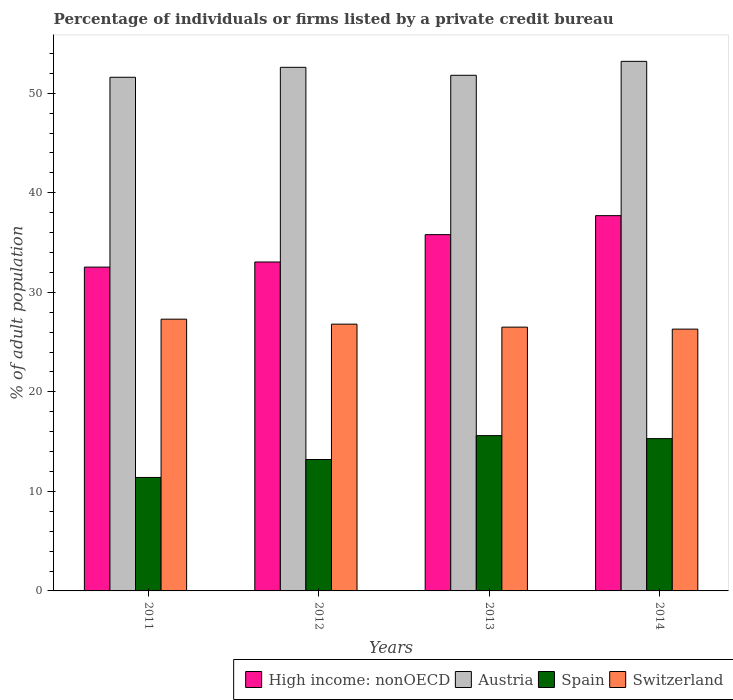How many different coloured bars are there?
Give a very brief answer. 4. Are the number of bars on each tick of the X-axis equal?
Ensure brevity in your answer.  Yes. How many bars are there on the 3rd tick from the right?
Ensure brevity in your answer.  4. What is the label of the 3rd group of bars from the left?
Your answer should be very brief. 2013. In how many cases, is the number of bars for a given year not equal to the number of legend labels?
Offer a very short reply. 0. Across all years, what is the maximum percentage of population listed by a private credit bureau in Spain?
Your answer should be compact. 15.6. Across all years, what is the minimum percentage of population listed by a private credit bureau in High income: nonOECD?
Your response must be concise. 32.53. In which year was the percentage of population listed by a private credit bureau in Austria maximum?
Offer a terse response. 2014. What is the total percentage of population listed by a private credit bureau in Spain in the graph?
Provide a succinct answer. 55.5. What is the difference between the percentage of population listed by a private credit bureau in Spain in 2011 and that in 2014?
Provide a short and direct response. -3.9. What is the difference between the percentage of population listed by a private credit bureau in Switzerland in 2012 and the percentage of population listed by a private credit bureau in High income: nonOECD in 2013?
Keep it short and to the point. -8.99. What is the average percentage of population listed by a private credit bureau in Switzerland per year?
Your answer should be compact. 26.72. In the year 2014, what is the difference between the percentage of population listed by a private credit bureau in Austria and percentage of population listed by a private credit bureau in High income: nonOECD?
Offer a terse response. 15.5. In how many years, is the percentage of population listed by a private credit bureau in Spain greater than 50 %?
Your response must be concise. 0. What is the ratio of the percentage of population listed by a private credit bureau in High income: nonOECD in 2013 to that in 2014?
Keep it short and to the point. 0.95. What is the difference between the highest and the second highest percentage of population listed by a private credit bureau in Austria?
Offer a terse response. 0.6. What is the difference between the highest and the lowest percentage of population listed by a private credit bureau in High income: nonOECD?
Offer a very short reply. 5.17. In how many years, is the percentage of population listed by a private credit bureau in High income: nonOECD greater than the average percentage of population listed by a private credit bureau in High income: nonOECD taken over all years?
Your response must be concise. 2. Is the sum of the percentage of population listed by a private credit bureau in Austria in 2012 and 2014 greater than the maximum percentage of population listed by a private credit bureau in High income: nonOECD across all years?
Ensure brevity in your answer.  Yes. What does the 1st bar from the left in 2011 represents?
Provide a succinct answer. High income: nonOECD. What does the 2nd bar from the right in 2012 represents?
Ensure brevity in your answer.  Spain. How many bars are there?
Provide a short and direct response. 16. Are all the bars in the graph horizontal?
Keep it short and to the point. No. How many years are there in the graph?
Make the answer very short. 4. What is the difference between two consecutive major ticks on the Y-axis?
Offer a very short reply. 10. Are the values on the major ticks of Y-axis written in scientific E-notation?
Your answer should be compact. No. Does the graph contain any zero values?
Keep it short and to the point. No. Where does the legend appear in the graph?
Ensure brevity in your answer.  Bottom right. How many legend labels are there?
Your answer should be very brief. 4. How are the legend labels stacked?
Offer a very short reply. Horizontal. What is the title of the graph?
Make the answer very short. Percentage of individuals or firms listed by a private credit bureau. What is the label or title of the Y-axis?
Provide a short and direct response. % of adult population. What is the % of adult population in High income: nonOECD in 2011?
Provide a short and direct response. 32.53. What is the % of adult population of Austria in 2011?
Provide a short and direct response. 51.6. What is the % of adult population of Switzerland in 2011?
Give a very brief answer. 27.3. What is the % of adult population in High income: nonOECD in 2012?
Provide a short and direct response. 33.04. What is the % of adult population of Austria in 2012?
Offer a terse response. 52.6. What is the % of adult population of Switzerland in 2012?
Provide a succinct answer. 26.8. What is the % of adult population of High income: nonOECD in 2013?
Your answer should be compact. 35.79. What is the % of adult population of Austria in 2013?
Offer a terse response. 51.8. What is the % of adult population of Switzerland in 2013?
Offer a terse response. 26.5. What is the % of adult population in High income: nonOECD in 2014?
Keep it short and to the point. 37.7. What is the % of adult population of Austria in 2014?
Provide a succinct answer. 53.2. What is the % of adult population of Switzerland in 2014?
Offer a very short reply. 26.3. Across all years, what is the maximum % of adult population of High income: nonOECD?
Offer a terse response. 37.7. Across all years, what is the maximum % of adult population in Austria?
Keep it short and to the point. 53.2. Across all years, what is the maximum % of adult population in Switzerland?
Ensure brevity in your answer.  27.3. Across all years, what is the minimum % of adult population of High income: nonOECD?
Make the answer very short. 32.53. Across all years, what is the minimum % of adult population in Austria?
Make the answer very short. 51.6. Across all years, what is the minimum % of adult population of Switzerland?
Your answer should be very brief. 26.3. What is the total % of adult population of High income: nonOECD in the graph?
Your answer should be very brief. 139.07. What is the total % of adult population of Austria in the graph?
Offer a terse response. 209.2. What is the total % of adult population of Spain in the graph?
Offer a very short reply. 55.5. What is the total % of adult population of Switzerland in the graph?
Offer a very short reply. 106.9. What is the difference between the % of adult population in High income: nonOECD in 2011 and that in 2012?
Make the answer very short. -0.51. What is the difference between the % of adult population in Spain in 2011 and that in 2012?
Keep it short and to the point. -1.8. What is the difference between the % of adult population of High income: nonOECD in 2011 and that in 2013?
Ensure brevity in your answer.  -3.26. What is the difference between the % of adult population of Austria in 2011 and that in 2013?
Your answer should be very brief. -0.2. What is the difference between the % of adult population in High income: nonOECD in 2011 and that in 2014?
Give a very brief answer. -5.17. What is the difference between the % of adult population in High income: nonOECD in 2012 and that in 2013?
Make the answer very short. -2.75. What is the difference between the % of adult population in Spain in 2012 and that in 2013?
Offer a very short reply. -2.4. What is the difference between the % of adult population of High income: nonOECD in 2012 and that in 2014?
Provide a succinct answer. -4.66. What is the difference between the % of adult population of Austria in 2012 and that in 2014?
Your answer should be compact. -0.6. What is the difference between the % of adult population of Spain in 2012 and that in 2014?
Make the answer very short. -2.1. What is the difference between the % of adult population in Switzerland in 2012 and that in 2014?
Your answer should be very brief. 0.5. What is the difference between the % of adult population in High income: nonOECD in 2013 and that in 2014?
Give a very brief answer. -1.91. What is the difference between the % of adult population of Austria in 2013 and that in 2014?
Provide a short and direct response. -1.4. What is the difference between the % of adult population of High income: nonOECD in 2011 and the % of adult population of Austria in 2012?
Give a very brief answer. -20.07. What is the difference between the % of adult population of High income: nonOECD in 2011 and the % of adult population of Spain in 2012?
Provide a short and direct response. 19.33. What is the difference between the % of adult population of High income: nonOECD in 2011 and the % of adult population of Switzerland in 2012?
Offer a terse response. 5.73. What is the difference between the % of adult population of Austria in 2011 and the % of adult population of Spain in 2012?
Your answer should be very brief. 38.4. What is the difference between the % of adult population of Austria in 2011 and the % of adult population of Switzerland in 2012?
Provide a short and direct response. 24.8. What is the difference between the % of adult population of Spain in 2011 and the % of adult population of Switzerland in 2012?
Provide a short and direct response. -15.4. What is the difference between the % of adult population in High income: nonOECD in 2011 and the % of adult population in Austria in 2013?
Offer a terse response. -19.27. What is the difference between the % of adult population in High income: nonOECD in 2011 and the % of adult population in Spain in 2013?
Provide a short and direct response. 16.93. What is the difference between the % of adult population in High income: nonOECD in 2011 and the % of adult population in Switzerland in 2013?
Make the answer very short. 6.03. What is the difference between the % of adult population of Austria in 2011 and the % of adult population of Switzerland in 2013?
Your answer should be very brief. 25.1. What is the difference between the % of adult population of Spain in 2011 and the % of adult population of Switzerland in 2013?
Ensure brevity in your answer.  -15.1. What is the difference between the % of adult population in High income: nonOECD in 2011 and the % of adult population in Austria in 2014?
Your answer should be very brief. -20.67. What is the difference between the % of adult population of High income: nonOECD in 2011 and the % of adult population of Spain in 2014?
Offer a very short reply. 17.23. What is the difference between the % of adult population of High income: nonOECD in 2011 and the % of adult population of Switzerland in 2014?
Ensure brevity in your answer.  6.23. What is the difference between the % of adult population of Austria in 2011 and the % of adult population of Spain in 2014?
Offer a terse response. 36.3. What is the difference between the % of adult population of Austria in 2011 and the % of adult population of Switzerland in 2014?
Provide a succinct answer. 25.3. What is the difference between the % of adult population in Spain in 2011 and the % of adult population in Switzerland in 2014?
Provide a short and direct response. -14.9. What is the difference between the % of adult population in High income: nonOECD in 2012 and the % of adult population in Austria in 2013?
Offer a terse response. -18.76. What is the difference between the % of adult population of High income: nonOECD in 2012 and the % of adult population of Spain in 2013?
Your answer should be compact. 17.44. What is the difference between the % of adult population in High income: nonOECD in 2012 and the % of adult population in Switzerland in 2013?
Provide a short and direct response. 6.54. What is the difference between the % of adult population of Austria in 2012 and the % of adult population of Spain in 2013?
Ensure brevity in your answer.  37. What is the difference between the % of adult population in Austria in 2012 and the % of adult population in Switzerland in 2013?
Provide a short and direct response. 26.1. What is the difference between the % of adult population of Spain in 2012 and the % of adult population of Switzerland in 2013?
Ensure brevity in your answer.  -13.3. What is the difference between the % of adult population of High income: nonOECD in 2012 and the % of adult population of Austria in 2014?
Provide a short and direct response. -20.16. What is the difference between the % of adult population in High income: nonOECD in 2012 and the % of adult population in Spain in 2014?
Ensure brevity in your answer.  17.74. What is the difference between the % of adult population in High income: nonOECD in 2012 and the % of adult population in Switzerland in 2014?
Ensure brevity in your answer.  6.74. What is the difference between the % of adult population of Austria in 2012 and the % of adult population of Spain in 2014?
Keep it short and to the point. 37.3. What is the difference between the % of adult population in Austria in 2012 and the % of adult population in Switzerland in 2014?
Provide a short and direct response. 26.3. What is the difference between the % of adult population of High income: nonOECD in 2013 and the % of adult population of Austria in 2014?
Give a very brief answer. -17.41. What is the difference between the % of adult population in High income: nonOECD in 2013 and the % of adult population in Spain in 2014?
Provide a short and direct response. 20.49. What is the difference between the % of adult population in High income: nonOECD in 2013 and the % of adult population in Switzerland in 2014?
Your response must be concise. 9.49. What is the difference between the % of adult population in Austria in 2013 and the % of adult population in Spain in 2014?
Keep it short and to the point. 36.5. What is the difference between the % of adult population of Spain in 2013 and the % of adult population of Switzerland in 2014?
Keep it short and to the point. -10.7. What is the average % of adult population in High income: nonOECD per year?
Keep it short and to the point. 34.77. What is the average % of adult population in Austria per year?
Offer a very short reply. 52.3. What is the average % of adult population of Spain per year?
Offer a very short reply. 13.88. What is the average % of adult population of Switzerland per year?
Provide a succinct answer. 26.73. In the year 2011, what is the difference between the % of adult population in High income: nonOECD and % of adult population in Austria?
Provide a short and direct response. -19.07. In the year 2011, what is the difference between the % of adult population in High income: nonOECD and % of adult population in Spain?
Provide a succinct answer. 21.13. In the year 2011, what is the difference between the % of adult population of High income: nonOECD and % of adult population of Switzerland?
Provide a short and direct response. 5.23. In the year 2011, what is the difference between the % of adult population in Austria and % of adult population in Spain?
Give a very brief answer. 40.2. In the year 2011, what is the difference between the % of adult population in Austria and % of adult population in Switzerland?
Provide a short and direct response. 24.3. In the year 2011, what is the difference between the % of adult population in Spain and % of adult population in Switzerland?
Provide a short and direct response. -15.9. In the year 2012, what is the difference between the % of adult population in High income: nonOECD and % of adult population in Austria?
Offer a very short reply. -19.56. In the year 2012, what is the difference between the % of adult population in High income: nonOECD and % of adult population in Spain?
Provide a short and direct response. 19.84. In the year 2012, what is the difference between the % of adult population in High income: nonOECD and % of adult population in Switzerland?
Your answer should be compact. 6.24. In the year 2012, what is the difference between the % of adult population of Austria and % of adult population of Spain?
Your answer should be very brief. 39.4. In the year 2012, what is the difference between the % of adult population in Austria and % of adult population in Switzerland?
Your answer should be compact. 25.8. In the year 2012, what is the difference between the % of adult population in Spain and % of adult population in Switzerland?
Offer a terse response. -13.6. In the year 2013, what is the difference between the % of adult population of High income: nonOECD and % of adult population of Austria?
Your response must be concise. -16.01. In the year 2013, what is the difference between the % of adult population in High income: nonOECD and % of adult population in Spain?
Keep it short and to the point. 20.19. In the year 2013, what is the difference between the % of adult population of High income: nonOECD and % of adult population of Switzerland?
Keep it short and to the point. 9.29. In the year 2013, what is the difference between the % of adult population of Austria and % of adult population of Spain?
Your response must be concise. 36.2. In the year 2013, what is the difference between the % of adult population of Austria and % of adult population of Switzerland?
Offer a very short reply. 25.3. In the year 2013, what is the difference between the % of adult population of Spain and % of adult population of Switzerland?
Offer a very short reply. -10.9. In the year 2014, what is the difference between the % of adult population of High income: nonOECD and % of adult population of Austria?
Keep it short and to the point. -15.5. In the year 2014, what is the difference between the % of adult population in High income: nonOECD and % of adult population in Spain?
Make the answer very short. 22.4. In the year 2014, what is the difference between the % of adult population of High income: nonOECD and % of adult population of Switzerland?
Your answer should be very brief. 11.4. In the year 2014, what is the difference between the % of adult population of Austria and % of adult population of Spain?
Make the answer very short. 37.9. In the year 2014, what is the difference between the % of adult population of Austria and % of adult population of Switzerland?
Your answer should be compact. 26.9. In the year 2014, what is the difference between the % of adult population in Spain and % of adult population in Switzerland?
Your response must be concise. -11. What is the ratio of the % of adult population of High income: nonOECD in 2011 to that in 2012?
Provide a short and direct response. 0.98. What is the ratio of the % of adult population in Austria in 2011 to that in 2012?
Make the answer very short. 0.98. What is the ratio of the % of adult population of Spain in 2011 to that in 2012?
Your answer should be compact. 0.86. What is the ratio of the % of adult population of Switzerland in 2011 to that in 2012?
Your answer should be compact. 1.02. What is the ratio of the % of adult population in High income: nonOECD in 2011 to that in 2013?
Your response must be concise. 0.91. What is the ratio of the % of adult population of Austria in 2011 to that in 2013?
Provide a short and direct response. 1. What is the ratio of the % of adult population in Spain in 2011 to that in 2013?
Offer a very short reply. 0.73. What is the ratio of the % of adult population in Switzerland in 2011 to that in 2013?
Provide a short and direct response. 1.03. What is the ratio of the % of adult population in High income: nonOECD in 2011 to that in 2014?
Give a very brief answer. 0.86. What is the ratio of the % of adult population in Austria in 2011 to that in 2014?
Keep it short and to the point. 0.97. What is the ratio of the % of adult population of Spain in 2011 to that in 2014?
Give a very brief answer. 0.75. What is the ratio of the % of adult population of Switzerland in 2011 to that in 2014?
Give a very brief answer. 1.04. What is the ratio of the % of adult population in High income: nonOECD in 2012 to that in 2013?
Your answer should be very brief. 0.92. What is the ratio of the % of adult population of Austria in 2012 to that in 2013?
Offer a very short reply. 1.02. What is the ratio of the % of adult population in Spain in 2012 to that in 2013?
Provide a short and direct response. 0.85. What is the ratio of the % of adult population of Switzerland in 2012 to that in 2013?
Make the answer very short. 1.01. What is the ratio of the % of adult population of High income: nonOECD in 2012 to that in 2014?
Your response must be concise. 0.88. What is the ratio of the % of adult population in Austria in 2012 to that in 2014?
Give a very brief answer. 0.99. What is the ratio of the % of adult population of Spain in 2012 to that in 2014?
Provide a short and direct response. 0.86. What is the ratio of the % of adult population of High income: nonOECD in 2013 to that in 2014?
Keep it short and to the point. 0.95. What is the ratio of the % of adult population of Austria in 2013 to that in 2014?
Your response must be concise. 0.97. What is the ratio of the % of adult population of Spain in 2013 to that in 2014?
Offer a very short reply. 1.02. What is the ratio of the % of adult population of Switzerland in 2013 to that in 2014?
Offer a terse response. 1.01. What is the difference between the highest and the second highest % of adult population of High income: nonOECD?
Provide a short and direct response. 1.91. What is the difference between the highest and the second highest % of adult population in Austria?
Your response must be concise. 0.6. What is the difference between the highest and the second highest % of adult population of Switzerland?
Your response must be concise. 0.5. What is the difference between the highest and the lowest % of adult population in High income: nonOECD?
Keep it short and to the point. 5.17. What is the difference between the highest and the lowest % of adult population in Switzerland?
Give a very brief answer. 1. 